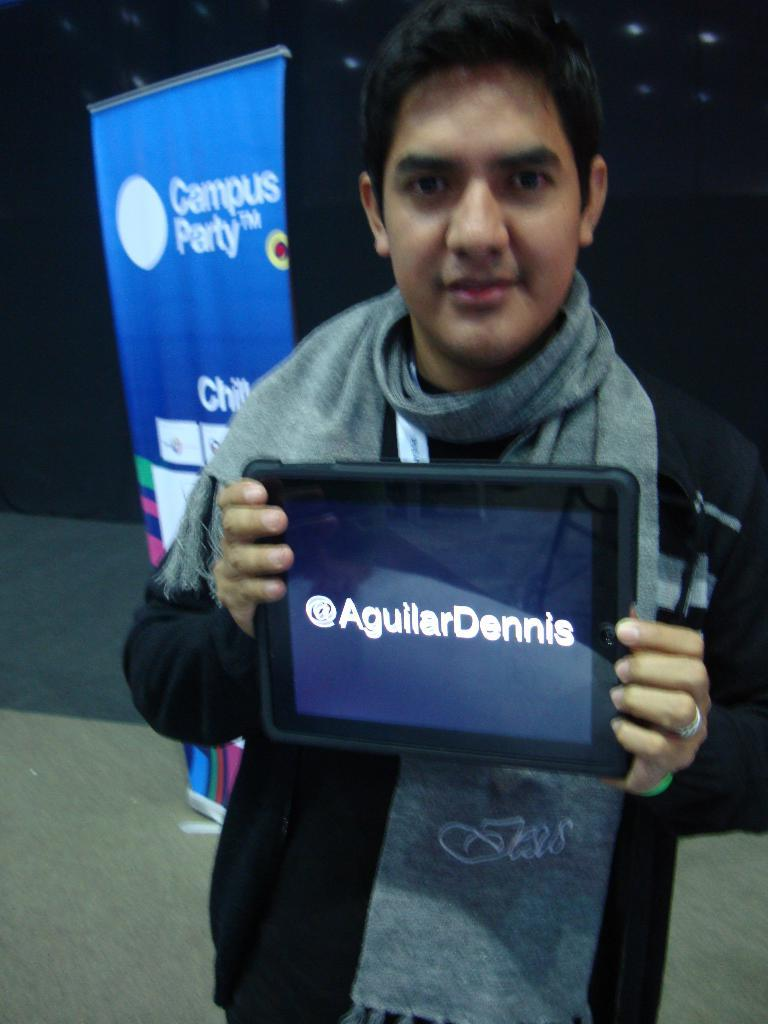Who is present in the image? There is a man in the image. Where is the man located in relation to the image? The man is standing in the foreground. What is the man holding in the image? The man is holding a gadget. What else can be seen in the image besides the man? There is a banner in the image. What type of jam is being spread on the pot in the image? There is no jam or pot present in the image. What number is written on the banner in the image? The provided facts do not mention any numbers on the banner, so we cannot determine the number from the image. 